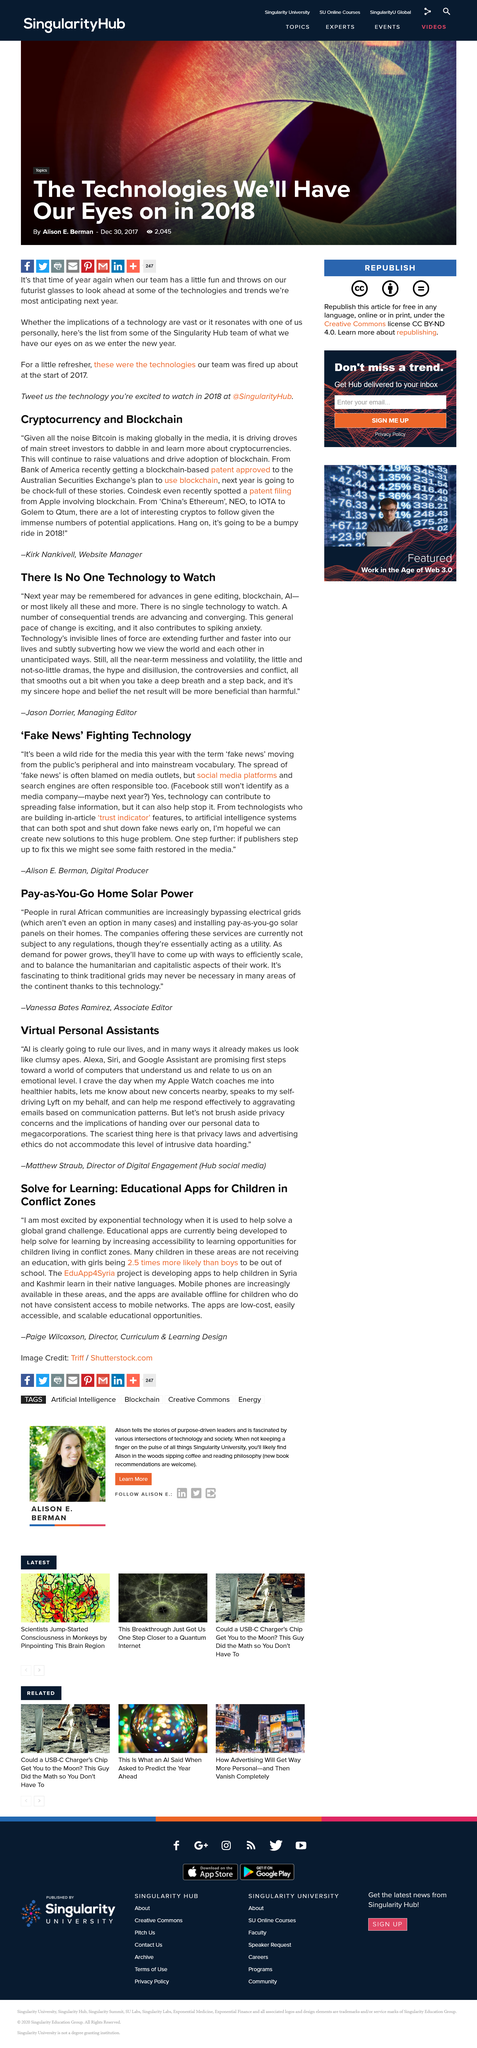Outline some significant characteristics in this image. The speaker believes that AI will dominate human life. The article discusses the potential impact of China's proposed cryptocurrency on the following popular cryptocurrencies: Ethereum, NEO, IOTA, Golem, and Qtum. The dabbling of main street investors in cryptocurrencies will lead to an increase in valuations and promote the adoption of blockchain technology. Girls are more likely to be out of school than boys. The term 'fake news' has entered mainstream vocabulary and is now widely recognized and used to describe false or misleading information. 